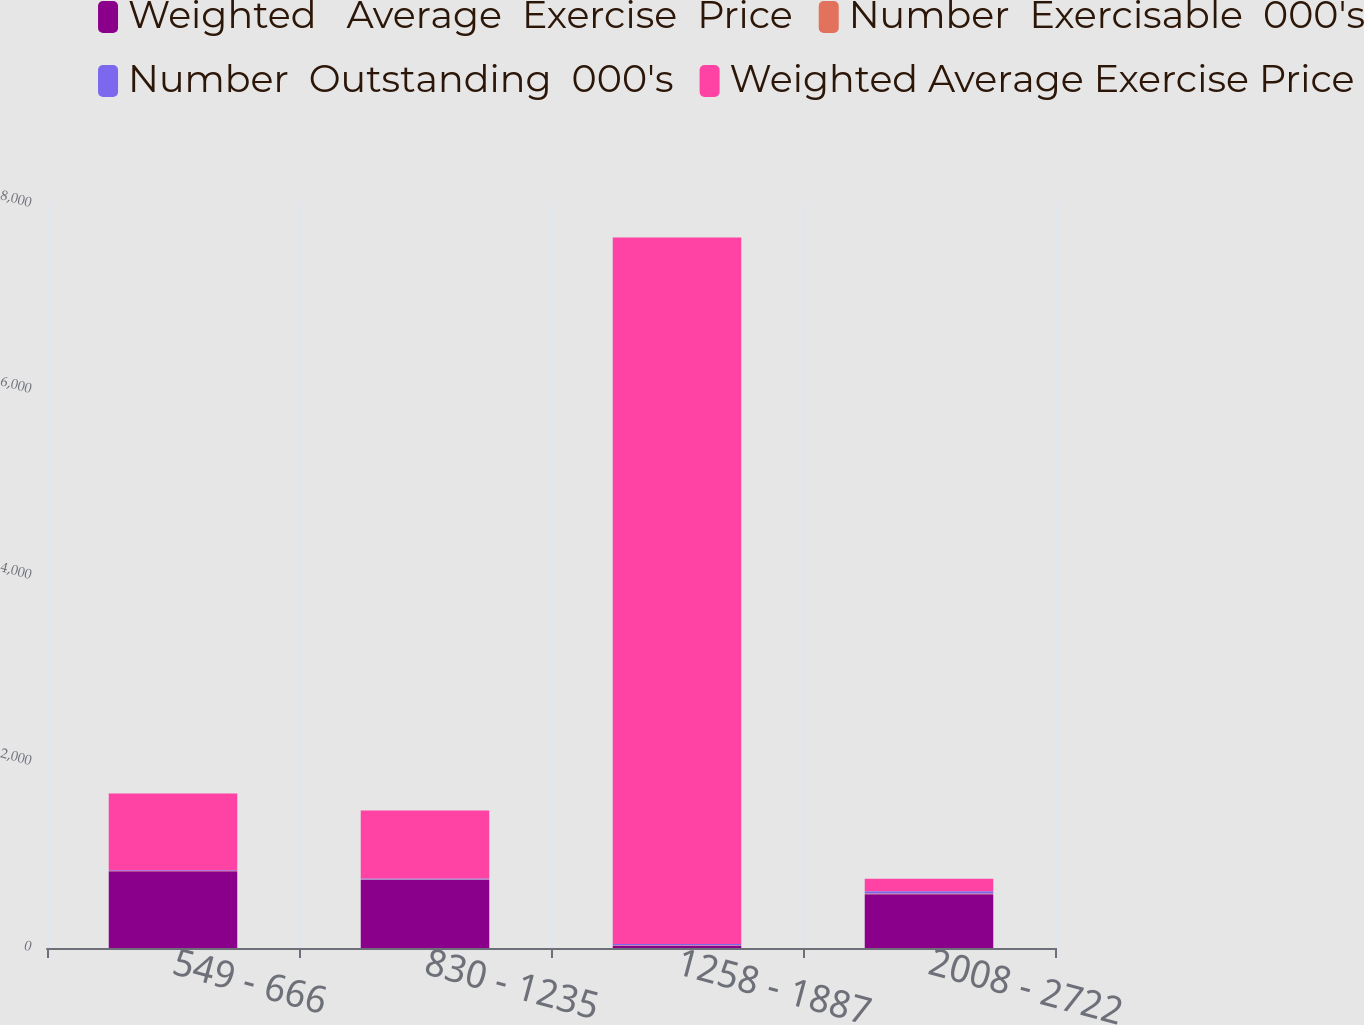Convert chart to OTSL. <chart><loc_0><loc_0><loc_500><loc_500><stacked_bar_chart><ecel><fcel>549 - 666<fcel>830 - 1235<fcel>1258 - 1887<fcel>2008 - 2722<nl><fcel>Weighted   Average  Exercise  Price<fcel>826<fcel>732<fcel>22.89<fcel>578<nl><fcel>Number  Exercisable  000's<fcel>2.5<fcel>3.6<fcel>6.8<fcel>8<nl><fcel>Number  Outstanding  000's<fcel>6.65<fcel>11.32<fcel>14.2<fcel>22.89<nl><fcel>Weighted Average Exercise Price<fcel>826<fcel>732<fcel>7596<fcel>137<nl></chart> 